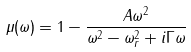Convert formula to latex. <formula><loc_0><loc_0><loc_500><loc_500>\mu ( \omega ) = 1 - \frac { A \omega ^ { 2 } } { \omega ^ { 2 } - \omega _ { r } ^ { 2 } + i \Gamma \omega }</formula> 